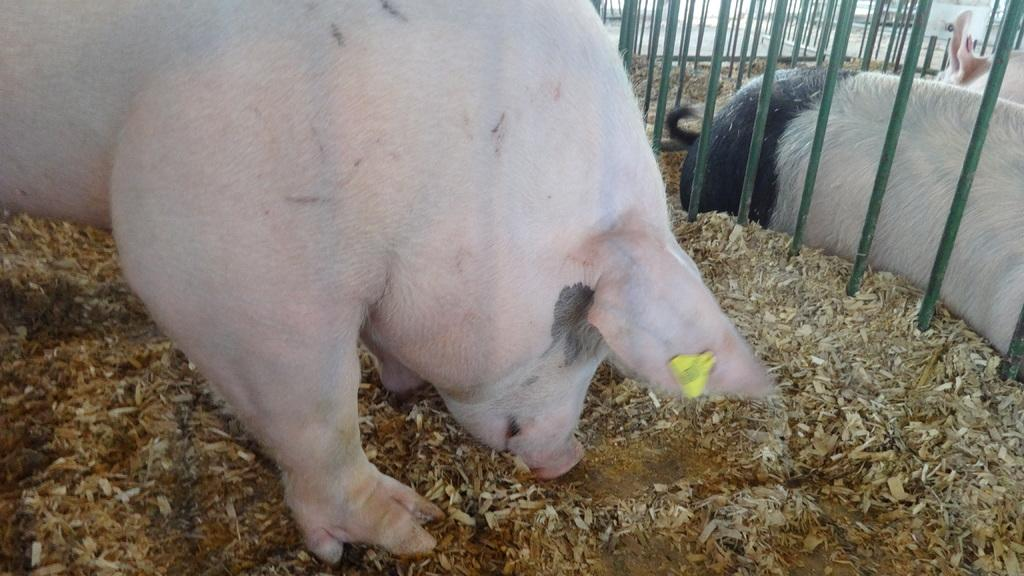What color is the pig in the image? The pig in the image is pink. Where are the pigs and cages located in the image? The pigs and cages are on the top right of the image. What type of harmony can be heard in the image? There is no sound or music present in the image, so it is not possible to determine the type of harmony. 